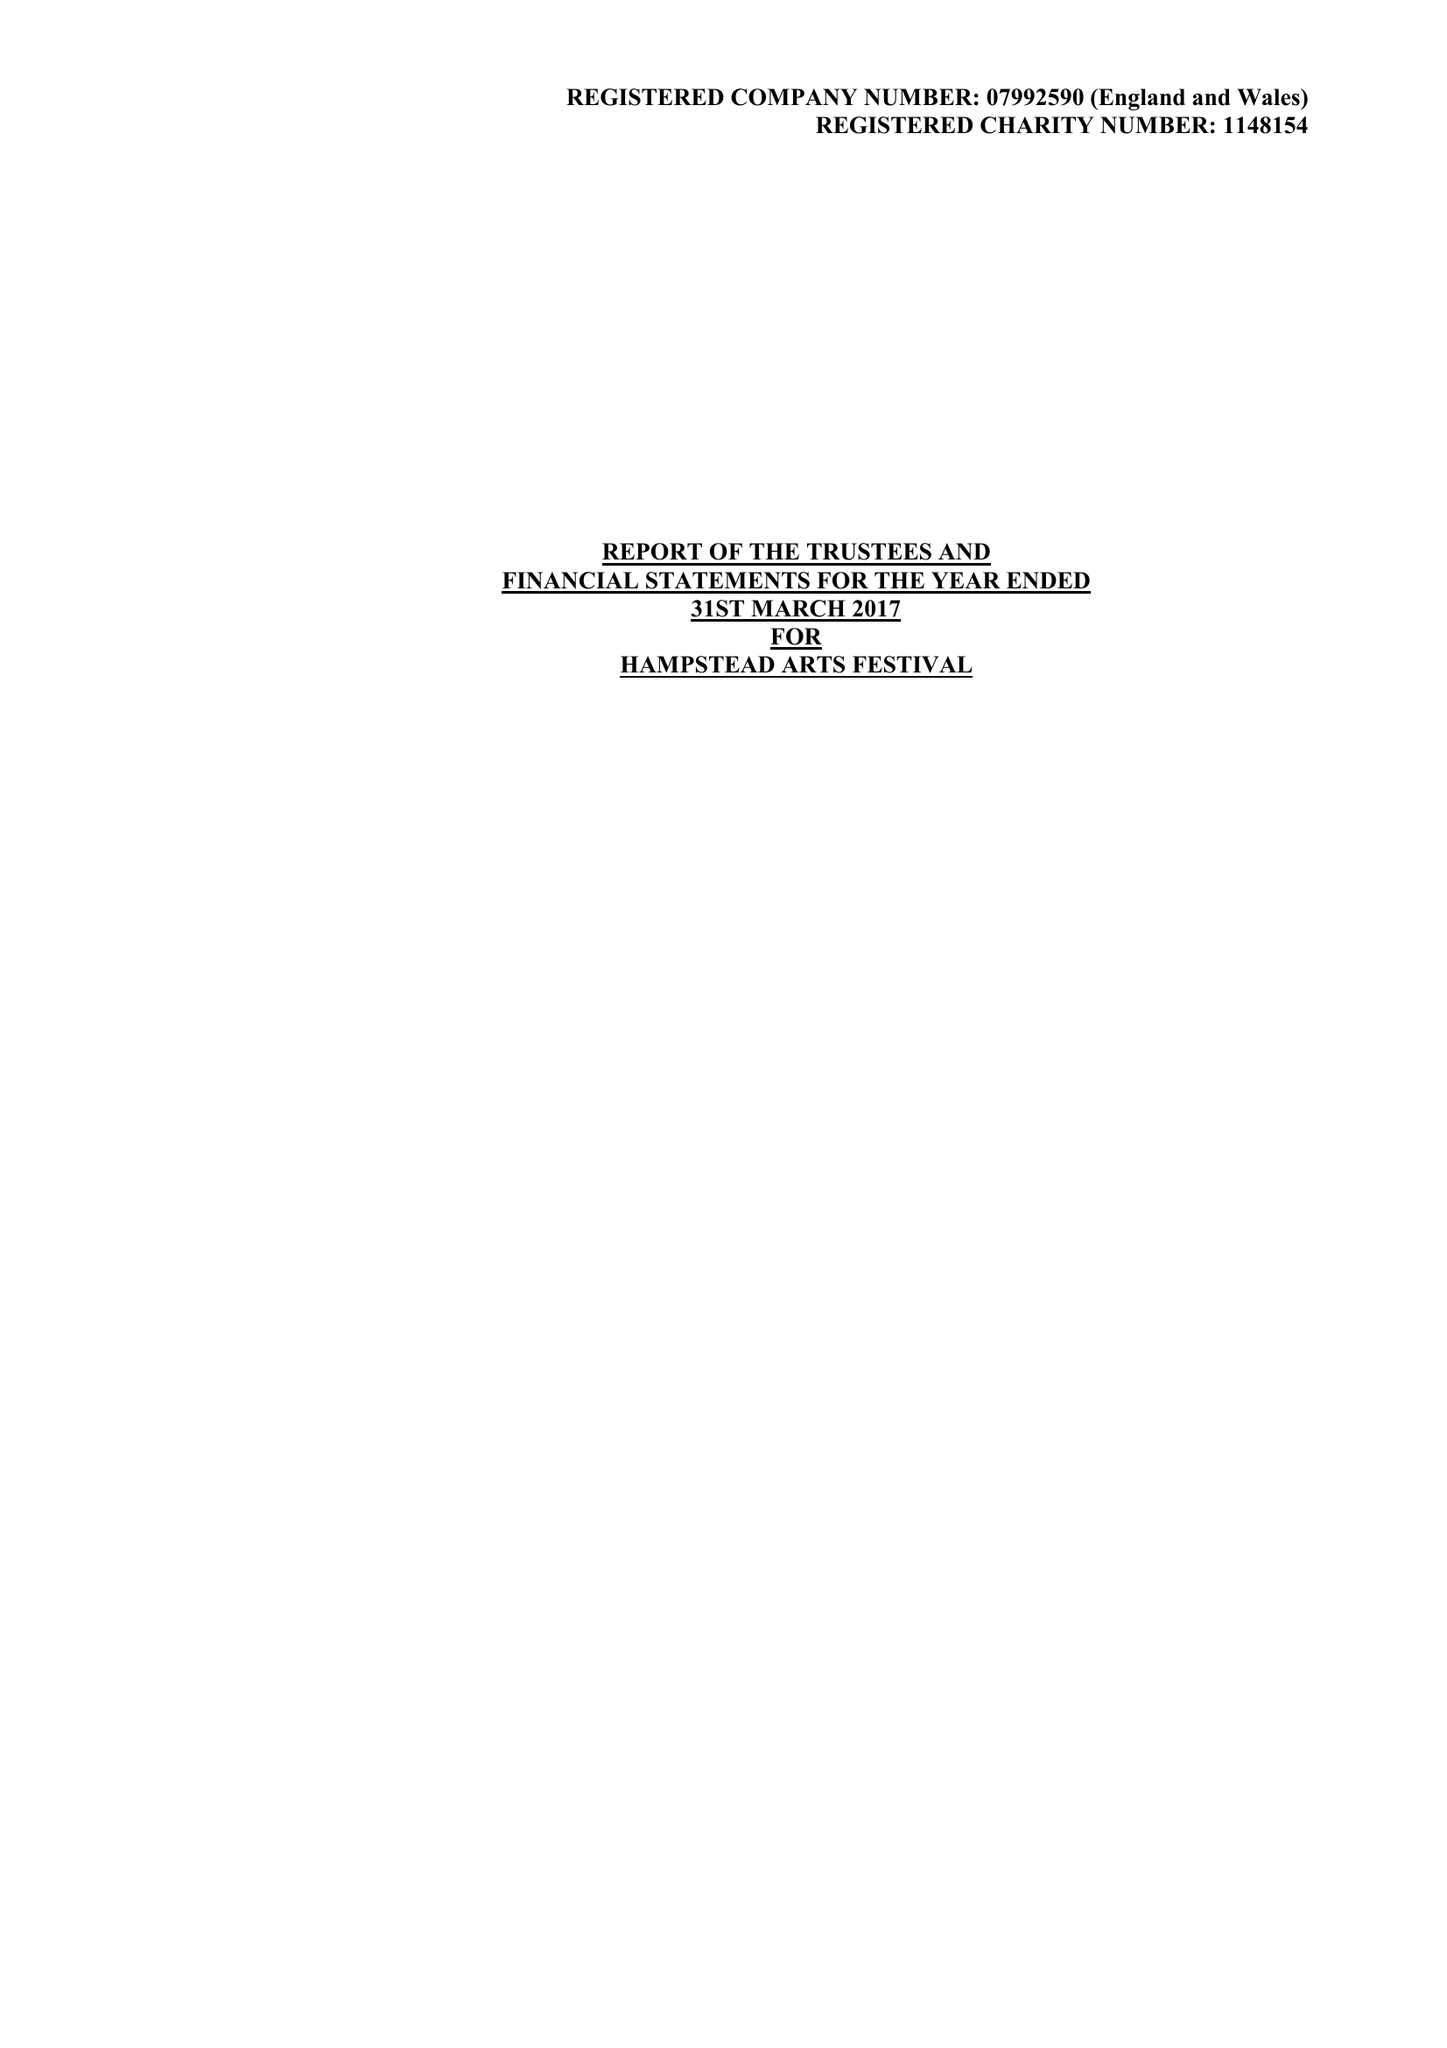What is the value for the spending_annually_in_british_pounds?
Answer the question using a single word or phrase. 49483.00 